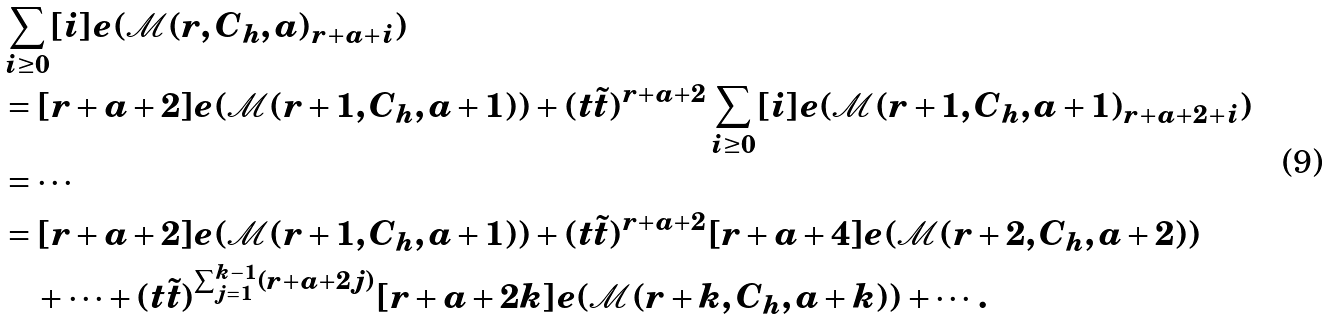Convert formula to latex. <formula><loc_0><loc_0><loc_500><loc_500>& \sum _ { i \geq 0 } [ i ] e ( \mathcal { M } ( r , C _ { h } , a ) _ { r + a + i } ) \\ & = [ r + a + 2 ] e ( \mathcal { M } ( r + 1 , C _ { h } , a + 1 ) ) + ( t \tilde { t } ) ^ { r + a + 2 } \sum _ { i \geq 0 } [ i ] e ( \mathcal { M } ( r + 1 , C _ { h } , a + 1 ) _ { r + a + 2 + i } ) \\ & = \cdots \\ & = [ r + a + 2 ] e ( \mathcal { M } ( r + 1 , C _ { h } , a + 1 ) ) + ( t \tilde { t } ) ^ { r + a + 2 } [ r + a + 4 ] e ( \mathcal { M } ( r + 2 , C _ { h } , a + 2 ) ) \\ & \quad + \dots + ( t \tilde { t } ) ^ { \sum _ { j = 1 } ^ { k - 1 } ( r + a + 2 j ) } [ r + a + 2 k ] e ( \mathcal { M } ( r + k , C _ { h } , a + k ) ) + \cdots .</formula> 